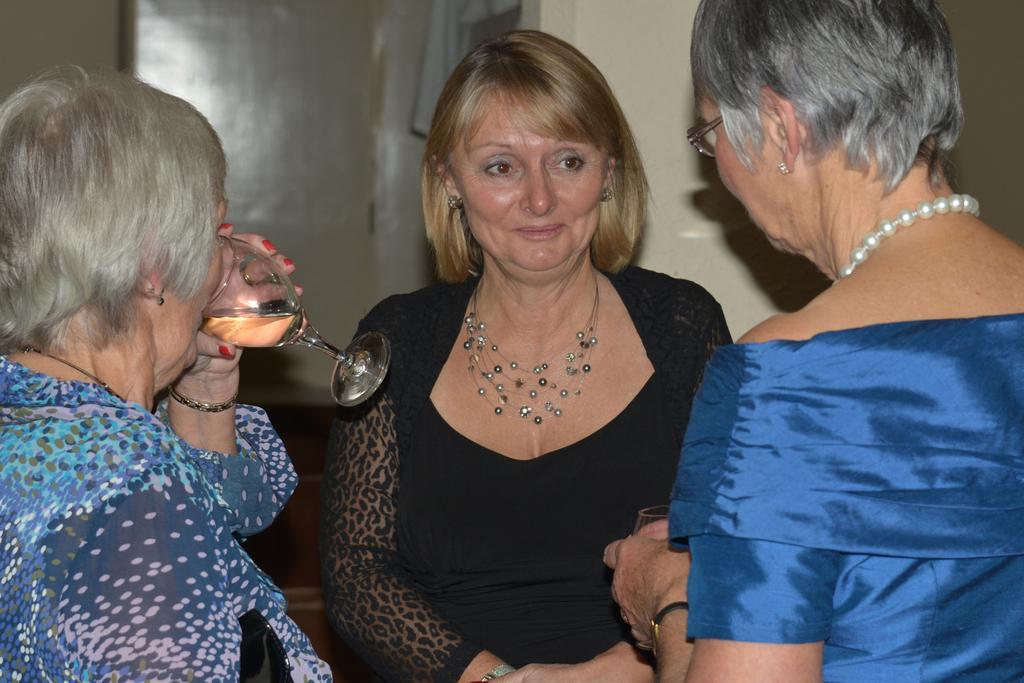In one or two sentences, can you explain what this image depicts? In this picture we can see three persons. she is in black color dress. And she hold a glass with her hand. On the left side she is drinking. And on the background there is a wall. 